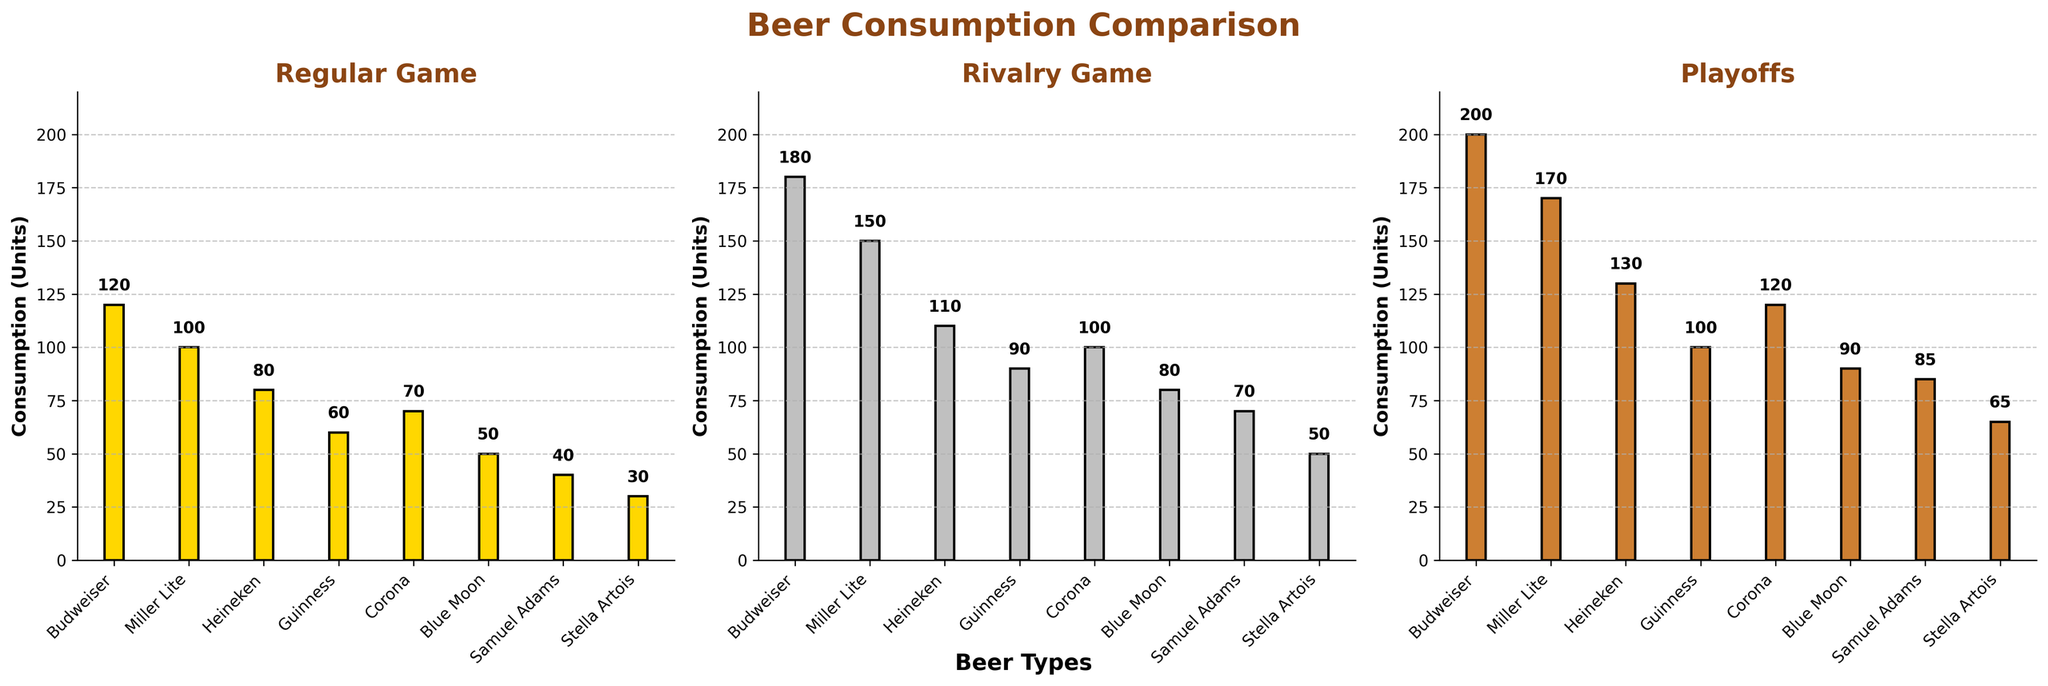How many types of beer are shown in the figure? Count the number of beer types listed on the x-axis of the bar charts. There are eight beer types shown: Budweiser, Miller Lite, Heineken, Guinness, Corona, Blue Moon, Samuel Adams, and Stella Artois
Answer: 8 What is the average beer consumption of Budweiser on regular game days across all types? Look at the height of the bars for Budweiser under regular game days and find the value, which is 120 units. Since Budweiser is only 1 type, the average is just the value itself
Answer: 120 Which beer has the highest consumption during rivalry games? Identify the tallest bar in the "Rivalry Game" subplot. It is the bar for Budweiser with a value of 180 units
Answer: Budweiser Is the consumption of Heineken greater during rivalry games or playoff games? Compare the bar heights of Heineken in both the rivalry and playoff subplots. For rivalry games, it's 110 units; for playoffs, it's 130 units, so playoff consumption is greater
Answer: Playoff games What is the total beer consumption of Guinness across all game days? Add the consumption values of Guinness from all three game days: 60 (Regular Game) + 90 (Rivalry Game) + 100 (Playoff). This gives 60 + 90 + 100 = 250
Answer: 250 Which beer has the smallest increase in consumption from regular games to playoff games? Calculate the difference between playoff and regular game consumptions for each beer and identify the smallest difference. Samuel Adams: 85 - 40 = 45, which is the smallest increase among others
Answer: Samuel Adams What’s the average consumption of beers on rivalry games? Sum the rivalry game values: 180 + 150 + 110 + 90 + 100 + 80 + 70 + 50 = 830. Then divide by the number of beer types (8). 830 / 8 = 103.75. So the average is 103.75
Answer: 103.75 Which beer sees the largest relative increase in consumption from regular games to rivalry games? Compute the relative increase: (rivalry - regular) / regular for each type and find the largest one. For instance, Budweiser: (180 - 120) / 120 = 50%, Miller Lite: (150 - 100) / 100 = 50%, and similarly for others. Guinness: (90 - 60) / 60 = 50%. You’ll see Blue Moon: (80 - 50) / 50 = 60% is the highest
Answer: Blue Moon Is the consumption of Corona higher in regular games or in playoff games? Compare the bar heights of Corona in both regular and playoff games. Regular: 70 units, Playoffs: 120 units. So it's higher in playoff games
Answer: Playoff games How much more Budweiser is consumed during playoffs compared to Samuel Adams during rivalry games? Subtract the Samuel Adams consumption during rivalry games from Budweiser during playoffs. Budweiser playoffs: 200, Samuel Adams rivalry: 70. So, 200 - 70 = 130
Answer: 130 